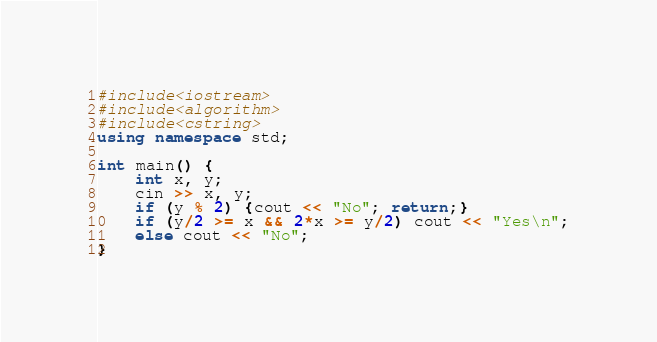<code> <loc_0><loc_0><loc_500><loc_500><_C++_>#include<iostream>
#include<algorithm>
#include<cstring>
using namespace std;

int main() {
    int x, y;
    cin >> x, y;
    if (y % 2) {cout << "No"; return;}
    if (y/2 >= x && 2*x >= y/2) cout << "Yes\n";
    else cout << "No";
}</code> 